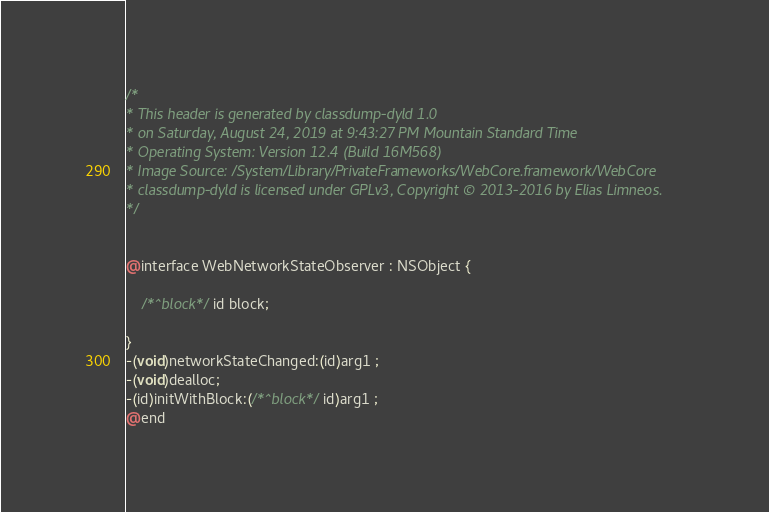Convert code to text. <code><loc_0><loc_0><loc_500><loc_500><_C_>/*
* This header is generated by classdump-dyld 1.0
* on Saturday, August 24, 2019 at 9:43:27 PM Mountain Standard Time
* Operating System: Version 12.4 (Build 16M568)
* Image Source: /System/Library/PrivateFrameworks/WebCore.framework/WebCore
* classdump-dyld is licensed under GPLv3, Copyright © 2013-2016 by Elias Limneos.
*/


@interface WebNetworkStateObserver : NSObject {

	/*^block*/id block;

}
-(void)networkStateChanged:(id)arg1 ;
-(void)dealloc;
-(id)initWithBlock:(/*^block*/id)arg1 ;
@end

</code> 